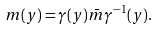<formula> <loc_0><loc_0><loc_500><loc_500>m ( y ) = \gamma ( y ) \bar { m } \gamma ^ { - 1 } ( y ) .</formula> 